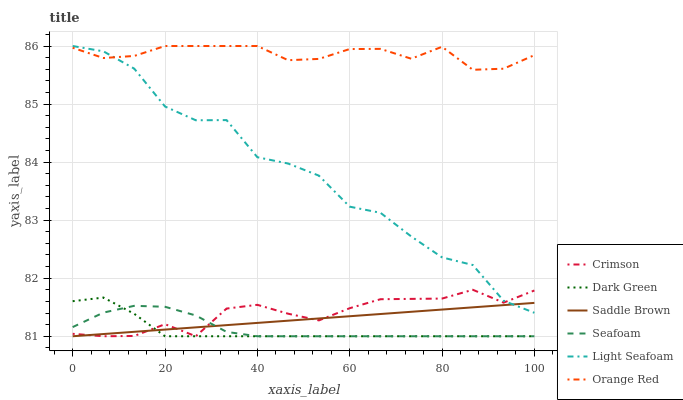Does Dark Green have the minimum area under the curve?
Answer yes or no. Yes. Does Orange Red have the maximum area under the curve?
Answer yes or no. Yes. Does Crimson have the minimum area under the curve?
Answer yes or no. No. Does Crimson have the maximum area under the curve?
Answer yes or no. No. Is Saddle Brown the smoothest?
Answer yes or no. Yes. Is Light Seafoam the roughest?
Answer yes or no. Yes. Is Orange Red the smoothest?
Answer yes or no. No. Is Orange Red the roughest?
Answer yes or no. No. Does Seafoam have the lowest value?
Answer yes or no. Yes. Does Orange Red have the lowest value?
Answer yes or no. No. Does Light Seafoam have the highest value?
Answer yes or no. Yes. Does Crimson have the highest value?
Answer yes or no. No. Is Saddle Brown less than Orange Red?
Answer yes or no. Yes. Is Orange Red greater than Crimson?
Answer yes or no. Yes. Does Saddle Brown intersect Crimson?
Answer yes or no. Yes. Is Saddle Brown less than Crimson?
Answer yes or no. No. Is Saddle Brown greater than Crimson?
Answer yes or no. No. Does Saddle Brown intersect Orange Red?
Answer yes or no. No. 